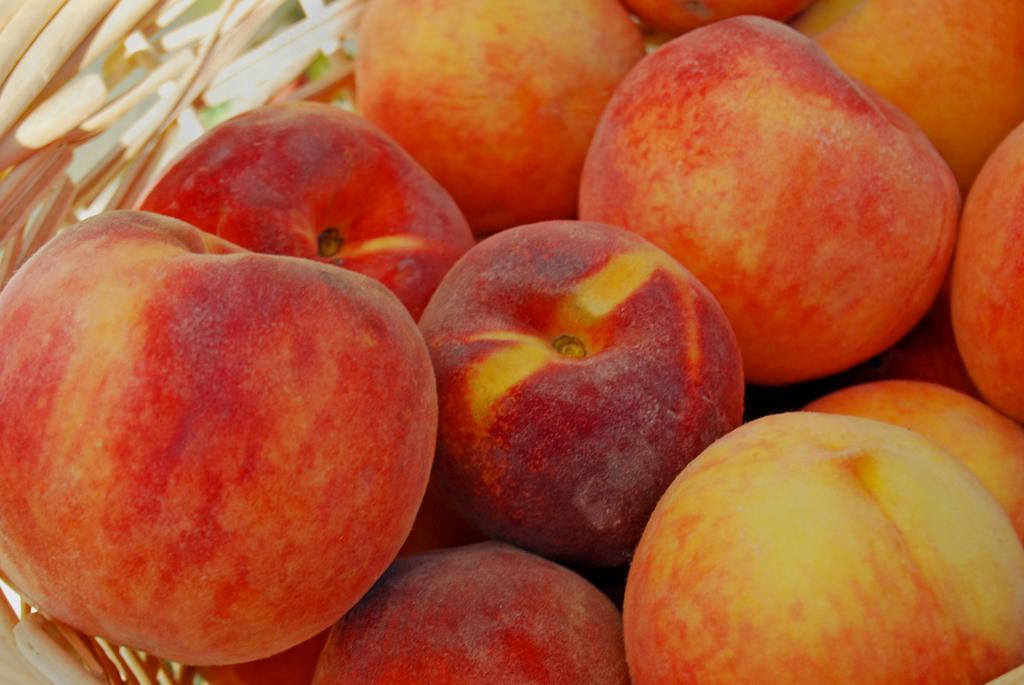Can you describe this image briefly? In this image I can see an apples which are in red and yellow color. These are in the wooden bowl. 